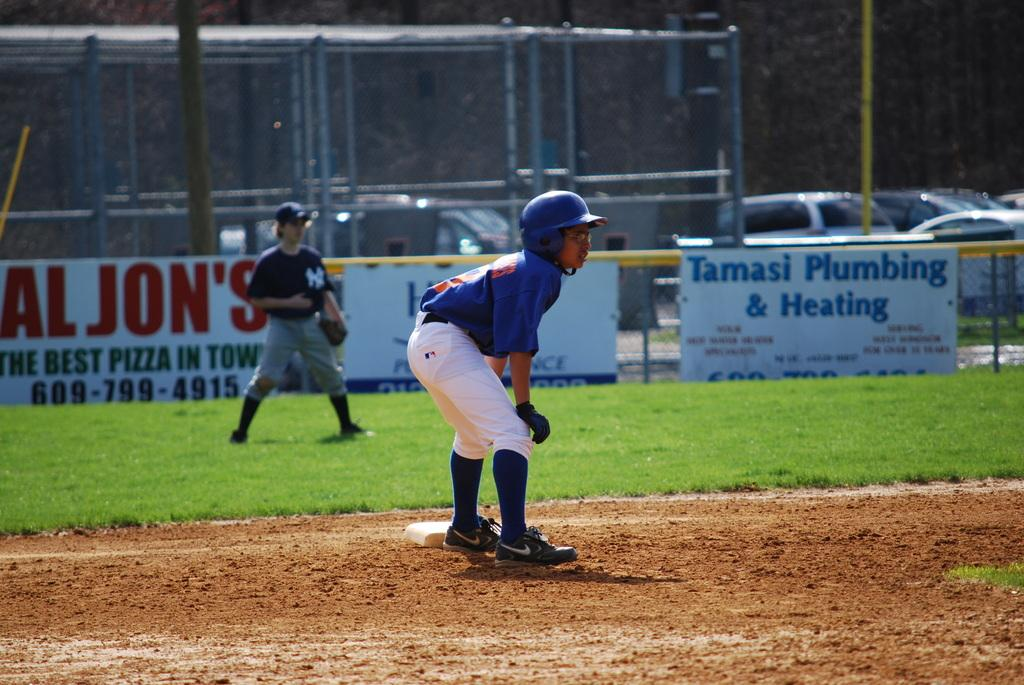Provide a one-sentence caption for the provided image. a tamasi plumbing and heating sign on the field. 